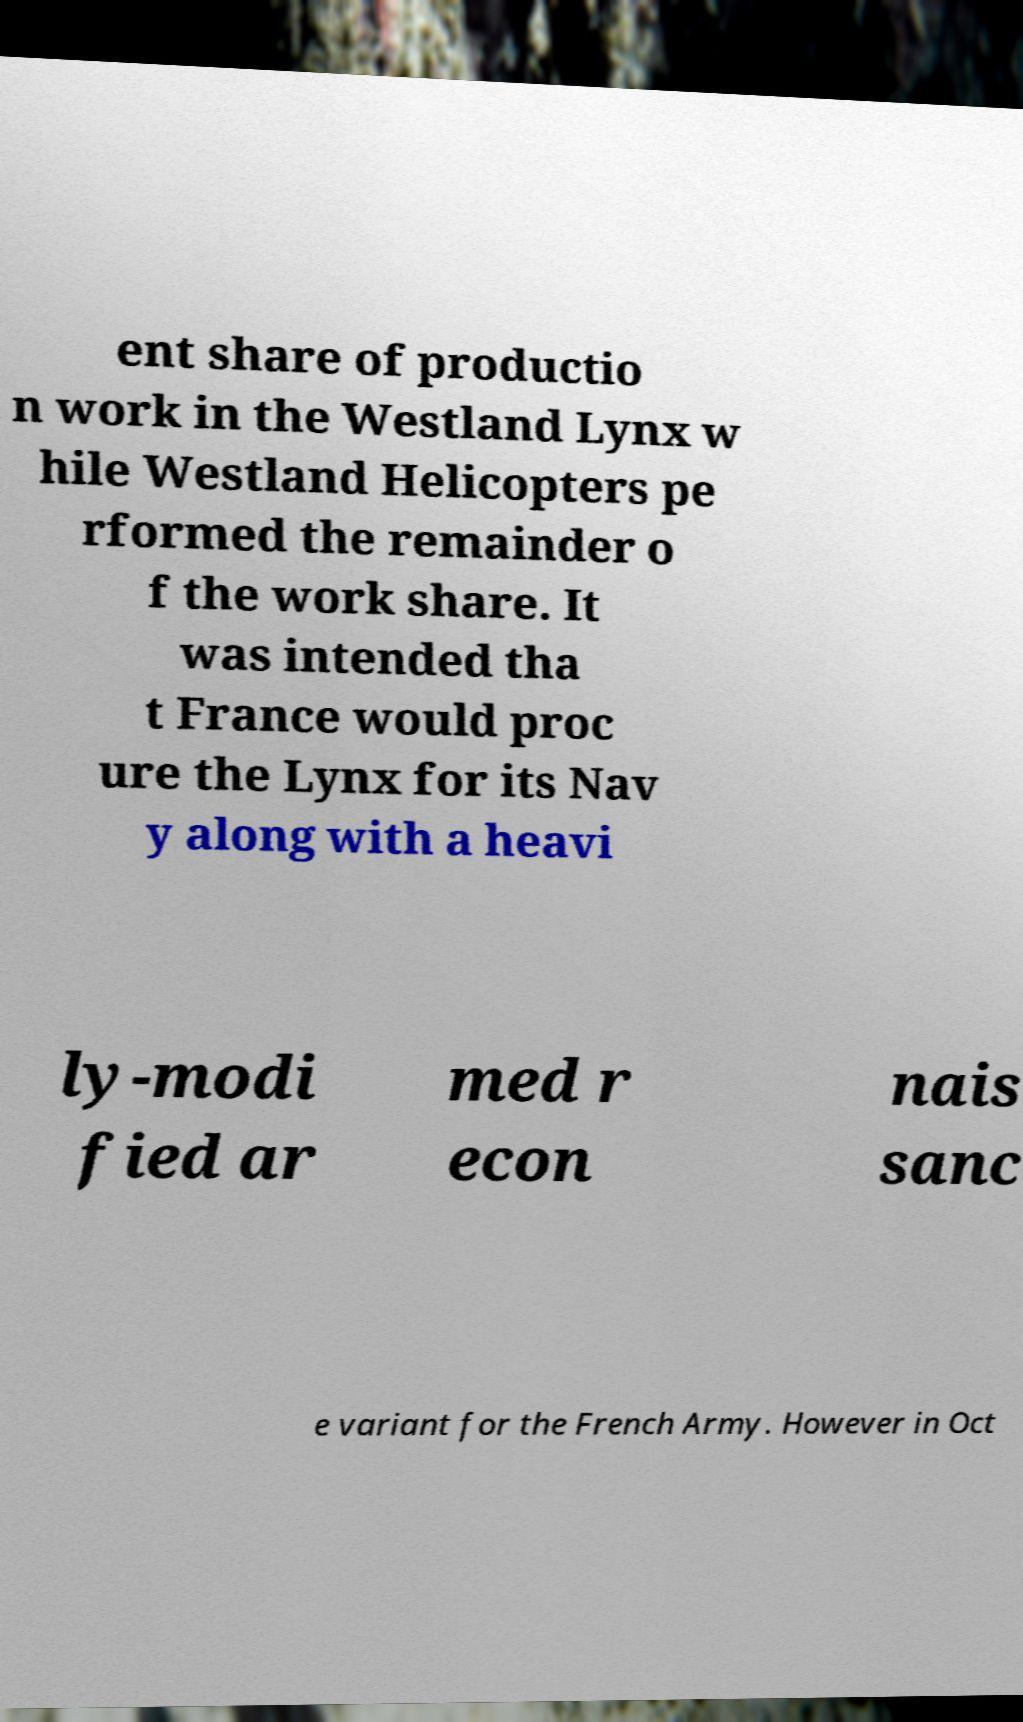I need the written content from this picture converted into text. Can you do that? ent share of productio n work in the Westland Lynx w hile Westland Helicopters pe rformed the remainder o f the work share. It was intended tha t France would proc ure the Lynx for its Nav y along with a heavi ly-modi fied ar med r econ nais sanc e variant for the French Army. However in Oct 